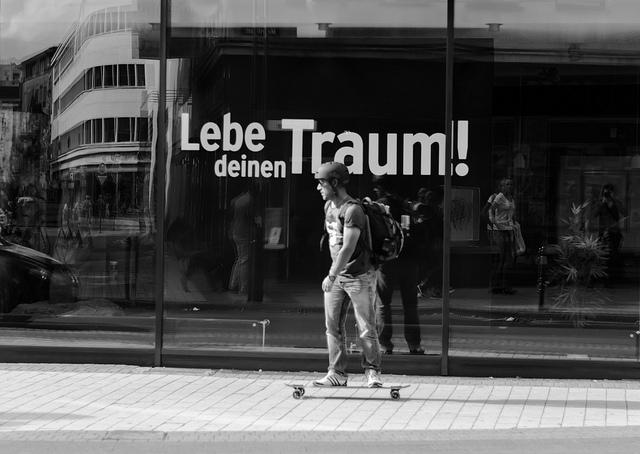What time of day is it likely to be?

Choices:
A) morning
B) afternoon
C) night
D) evening afternoon 